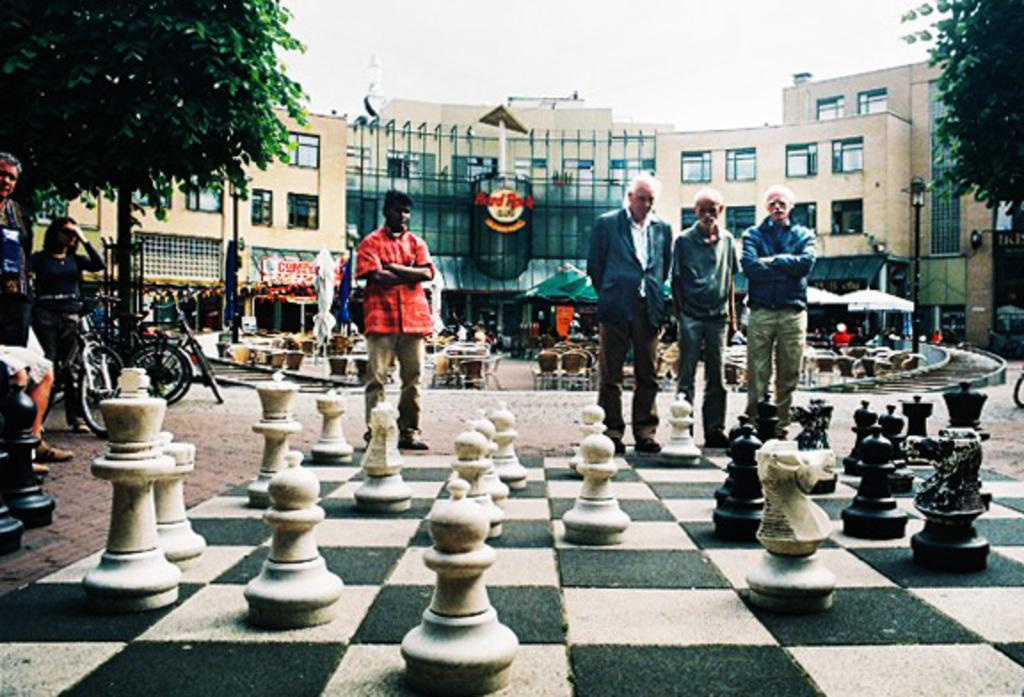<image>
Render a clear and concise summary of the photo. men looking down at giant chessboard on the ground and the hard rock sign on building behind them 